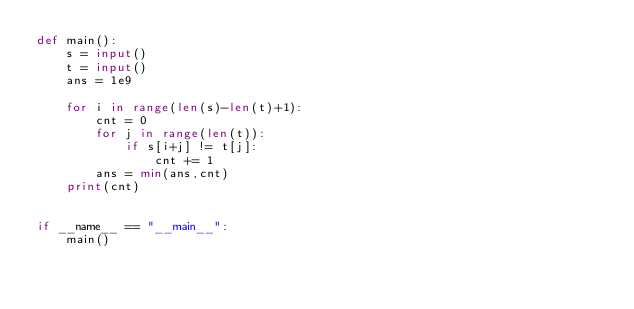Convert code to text. <code><loc_0><loc_0><loc_500><loc_500><_Python_>def main():
    s = input()
    t = input()
    ans = 1e9
    
    for i in range(len(s)-len(t)+1):
        cnt = 0
        for j in range(len(t)):
            if s[i+j] != t[j]:
                cnt += 1
        ans = min(ans,cnt)
    print(cnt)
    

if __name__ == "__main__":
    main()</code> 